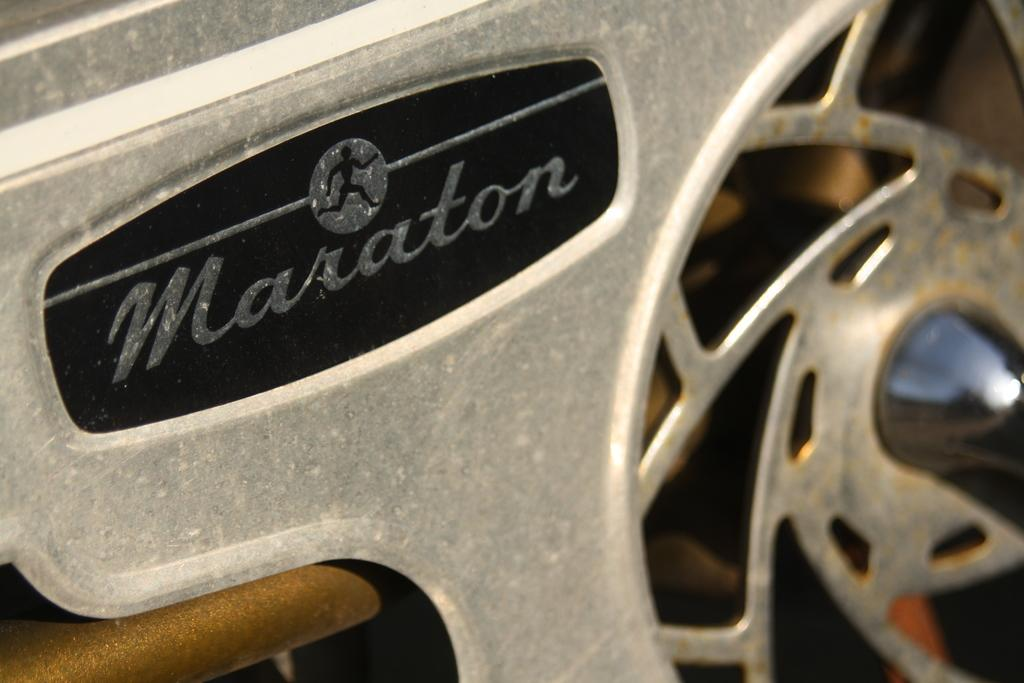What type of object is present in the image? There is a metal object in the image. Can you describe the design or logo on the metal object? The metal object has a person logo. How many actors are visible in the image? There are no actors present in the image; it features a metal object with a person logo. Can you describe the trail left by the ant in the image? There is no ant or trail present in the image. 